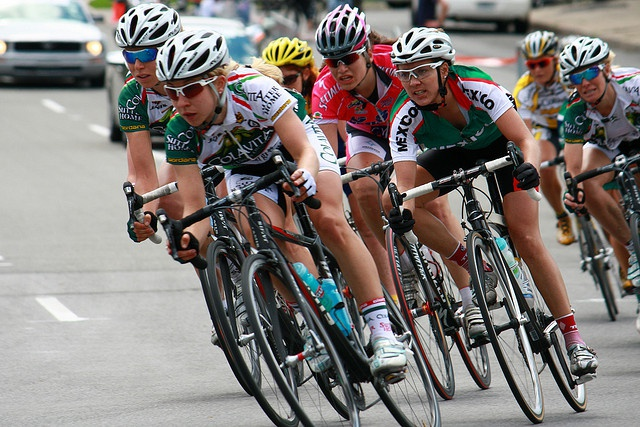Describe the objects in this image and their specific colors. I can see people in white, black, lightgray, brown, and maroon tones, people in white, black, maroon, brown, and lavender tones, people in white, black, maroon, brown, and gray tones, bicycle in white, black, darkgray, gray, and lightgray tones, and bicycle in white, black, darkgray, gray, and lightgray tones in this image. 